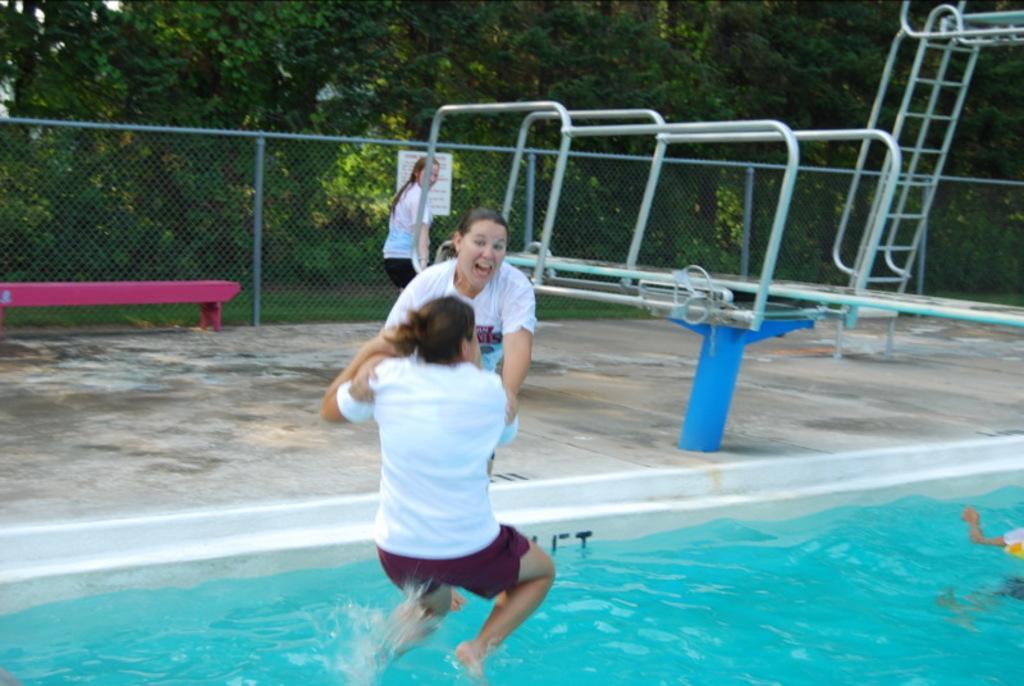How would you summarize this image in a sentence or two? In this picture we can see few people, in the middle of the image we can see a woman. she is jumping into the water, behind her we can find few metal rods, fence and trees. 